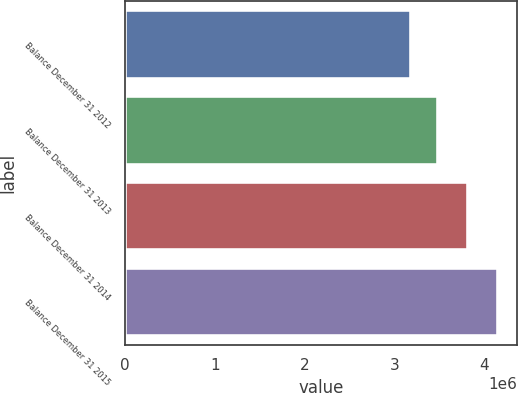<chart> <loc_0><loc_0><loc_500><loc_500><bar_chart><fcel>Balance December 31 2012<fcel>Balance December 31 2013<fcel>Balance December 31 2014<fcel>Balance December 31 2015<nl><fcel>3.17618e+06<fcel>3.47776e+06<fcel>3.8152e+06<fcel>4.14991e+06<nl></chart> 